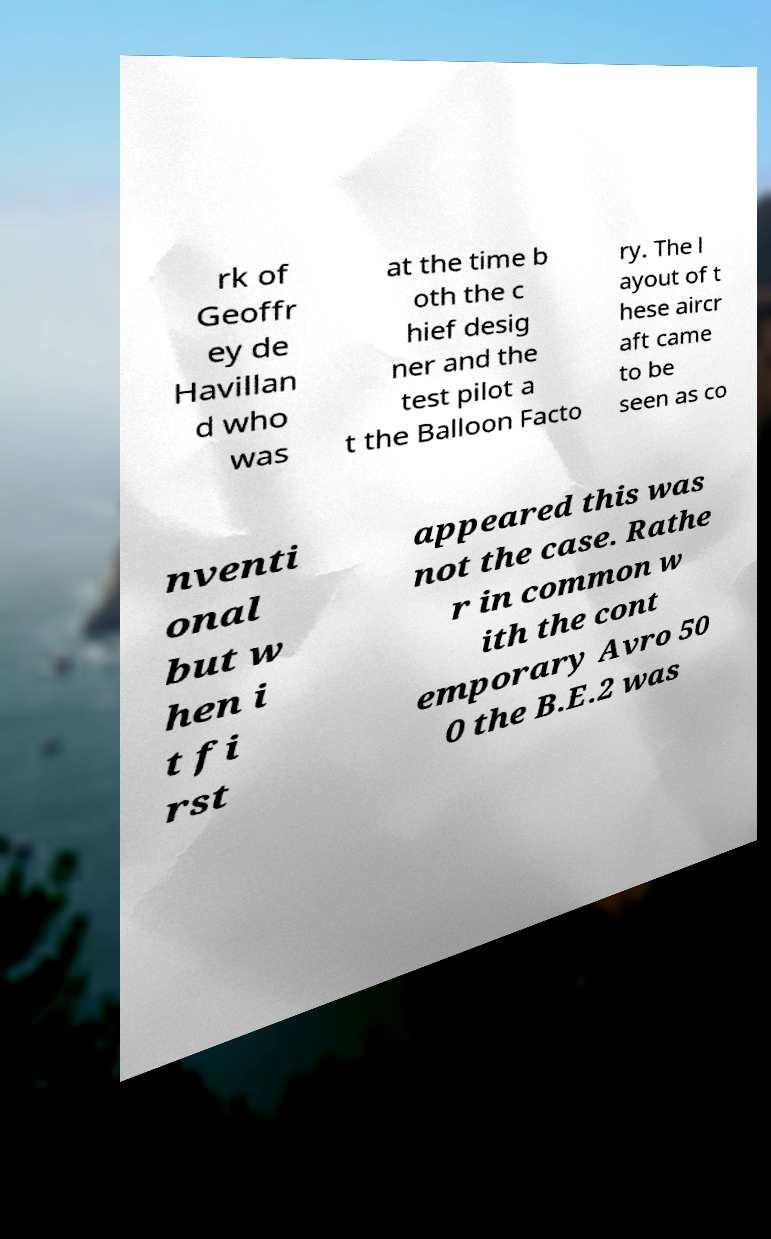Please identify and transcribe the text found in this image. rk of Geoffr ey de Havillan d who was at the time b oth the c hief desig ner and the test pilot a t the Balloon Facto ry. The l ayout of t hese aircr aft came to be seen as co nventi onal but w hen i t fi rst appeared this was not the case. Rathe r in common w ith the cont emporary Avro 50 0 the B.E.2 was 